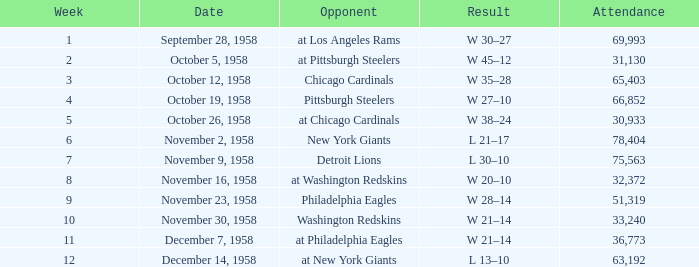What day had over 51,319 attending week 4? October 19, 1958. 